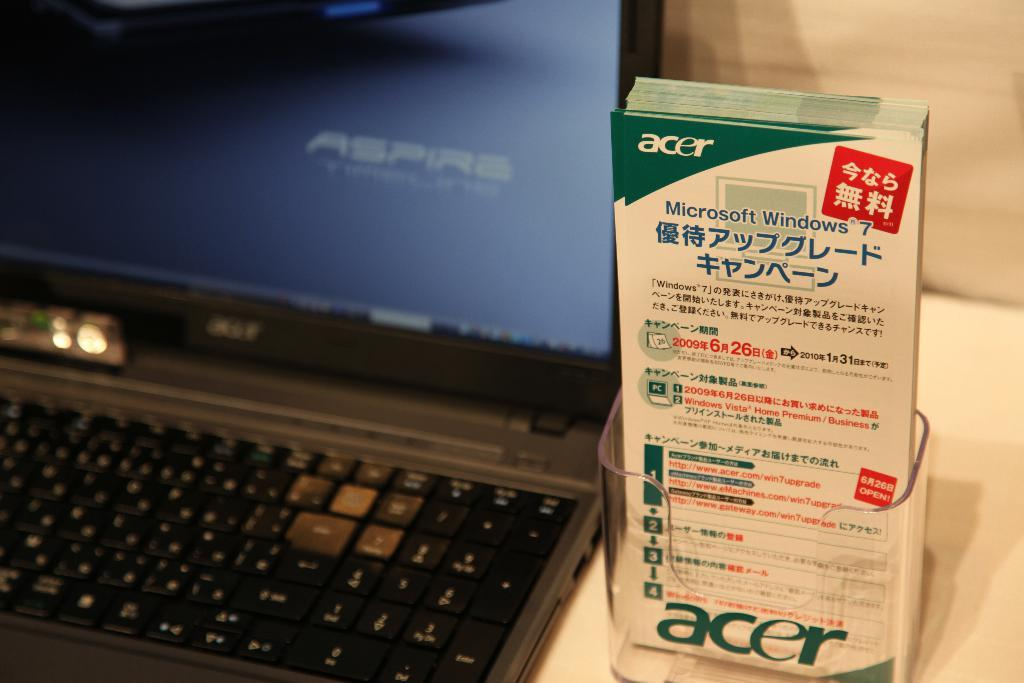<image>
Give a short and clear explanation of the subsequent image. A pamphlet reading "acer" in the left corner next to a black lap top with an ASPIRE logo on thte screen. 